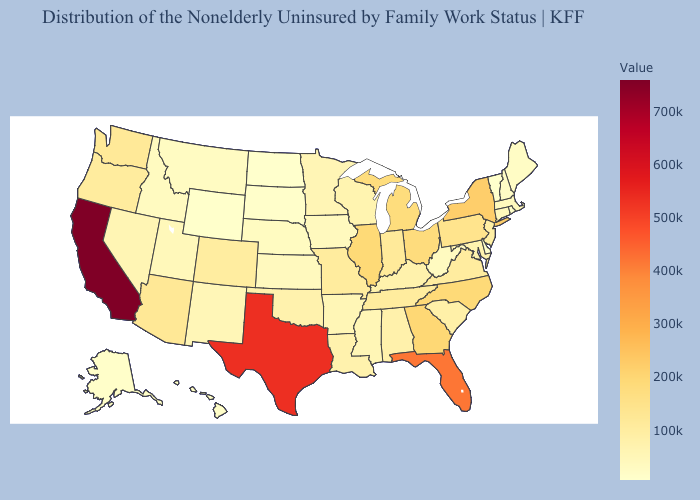Among the states that border Colorado , does Wyoming have the lowest value?
Write a very short answer. Yes. Among the states that border Indiana , which have the lowest value?
Keep it brief. Kentucky. Which states have the highest value in the USA?
Write a very short answer. California. Does Nebraska have a lower value than Texas?
Give a very brief answer. Yes. Among the states that border Ohio , which have the highest value?
Give a very brief answer. Michigan. Does Mississippi have a higher value than North Carolina?
Be succinct. No. Which states have the lowest value in the USA?
Be succinct. North Dakota. Does Florida have the lowest value in the South?
Give a very brief answer. No. 